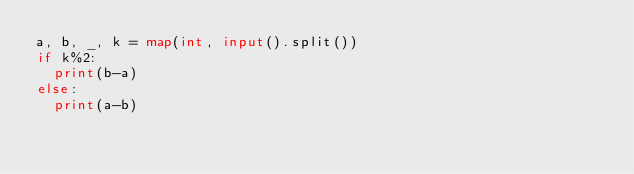Convert code to text. <code><loc_0><loc_0><loc_500><loc_500><_Python_>a, b, _, k = map(int, input().split())
if k%2:
  print(b-a)
else:
  print(a-b)</code> 